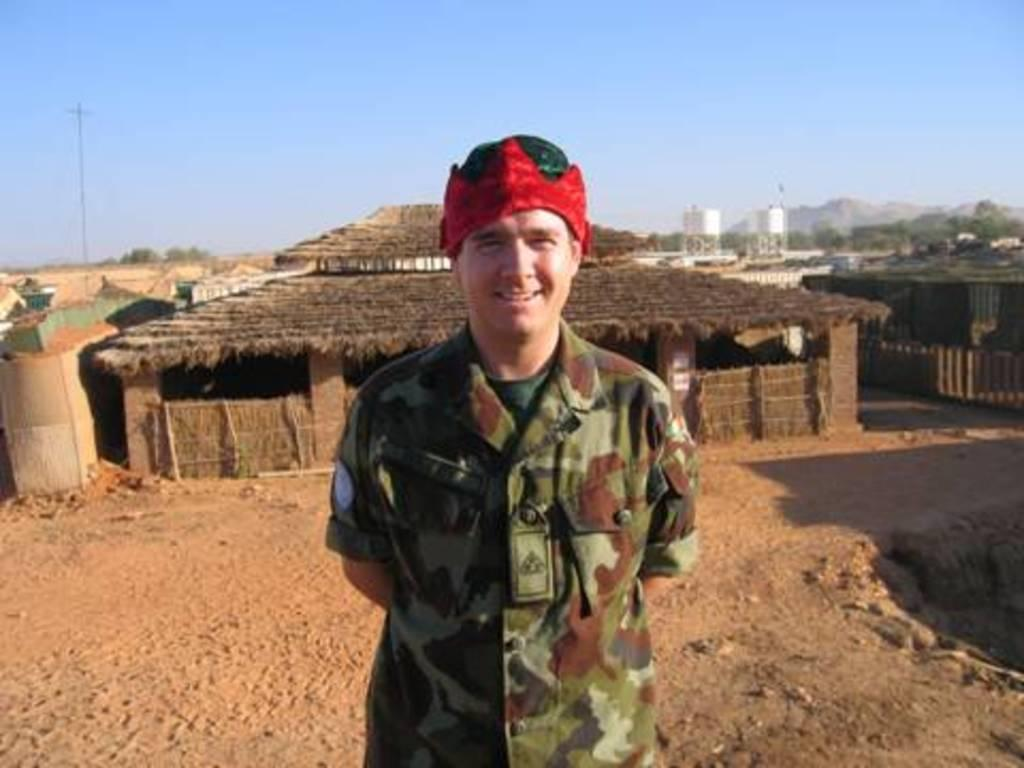Who is present in the image? There is a man in the image. What is the man's facial expression? The man is smiling. What can be seen in the background of the image? There are houses, poles, trees, and hills visible in the background. What type of needle is the man holding in the image? There is no needle present in the image; the man is simply smiling. 